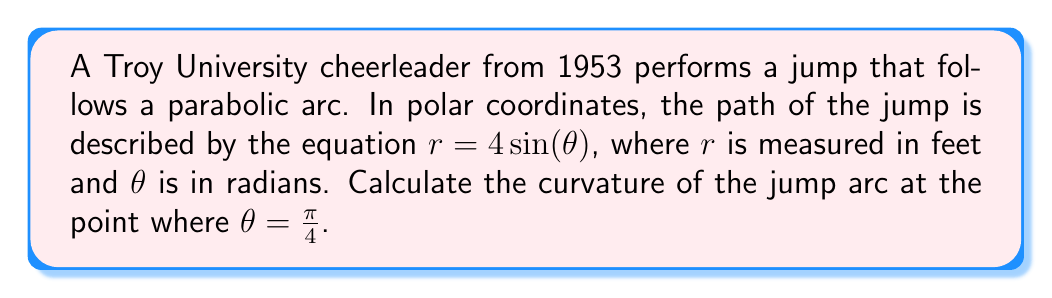Give your solution to this math problem. To find the curvature of the jump arc, we'll follow these steps:

1) The curvature formula in polar coordinates is:

   $$\kappa = \frac{|r^2 + 2(r')^2 - rr''|}{(r^2 + (r')^2)^{3/2}}$$

2) We need to find $r$, $r'$, and $r''$:
   
   $r = 4\sin(\theta)$
   $r' = 4\cos(\theta)$
   $r'' = -4\sin(\theta)$

3) At $\theta = \frac{\pi}{4}$:
   
   $r = 4\sin(\frac{\pi}{4}) = 2\sqrt{2}$
   $r' = 4\cos(\frac{\pi}{4}) = 2\sqrt{2}$
   $r'' = -4\sin(\frac{\pi}{4}) = -2\sqrt{2}$

4) Now, let's substitute these values into the curvature formula:

   $$\kappa = \frac{|(2\sqrt{2})^2 + 2(2\sqrt{2})^2 - (2\sqrt{2})(-2\sqrt{2})|}{((2\sqrt{2})^2 + (2\sqrt{2})^2)^{3/2}}$$

5) Simplify:
   
   $$\kappa = \frac{|8 + 16 + 8|}{(8 + 8)^{3/2}} = \frac{32}{16^{3/2}} = \frac{32}{64} = \frac{1}{2}$$

Therefore, the curvature of the cheerleader's jump arc at $\theta = \frac{\pi}{4}$ is $\frac{1}{2}$ ft$^{-1}$.
Answer: $\frac{1}{2}$ ft$^{-1}$ 